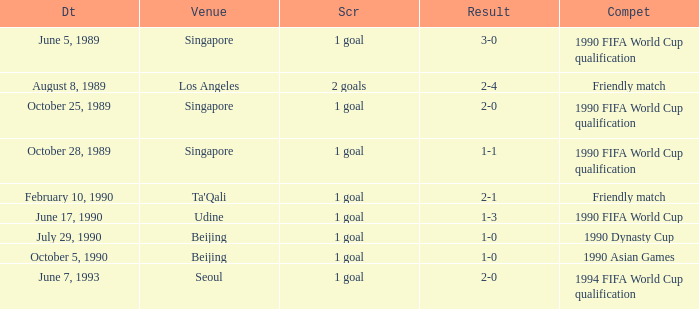What was the score of the match with a 3-0 result? 1 goal. 